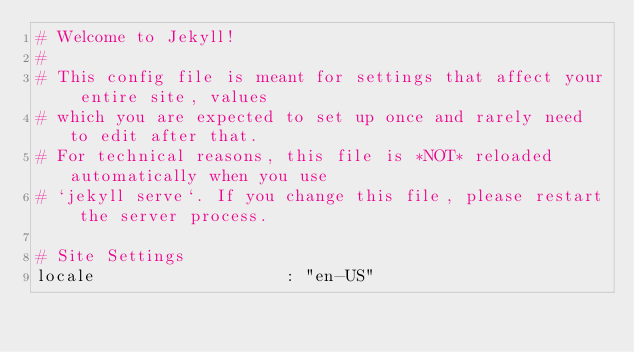Convert code to text. <code><loc_0><loc_0><loc_500><loc_500><_YAML_># Welcome to Jekyll!
#
# This config file is meant for settings that affect your entire site, values
# which you are expected to set up once and rarely need to edit after that.
# For technical reasons, this file is *NOT* reloaded automatically when you use
# `jekyll serve`. If you change this file, please restart the server process.

# Site Settings
locale                   : "en-US"</code> 